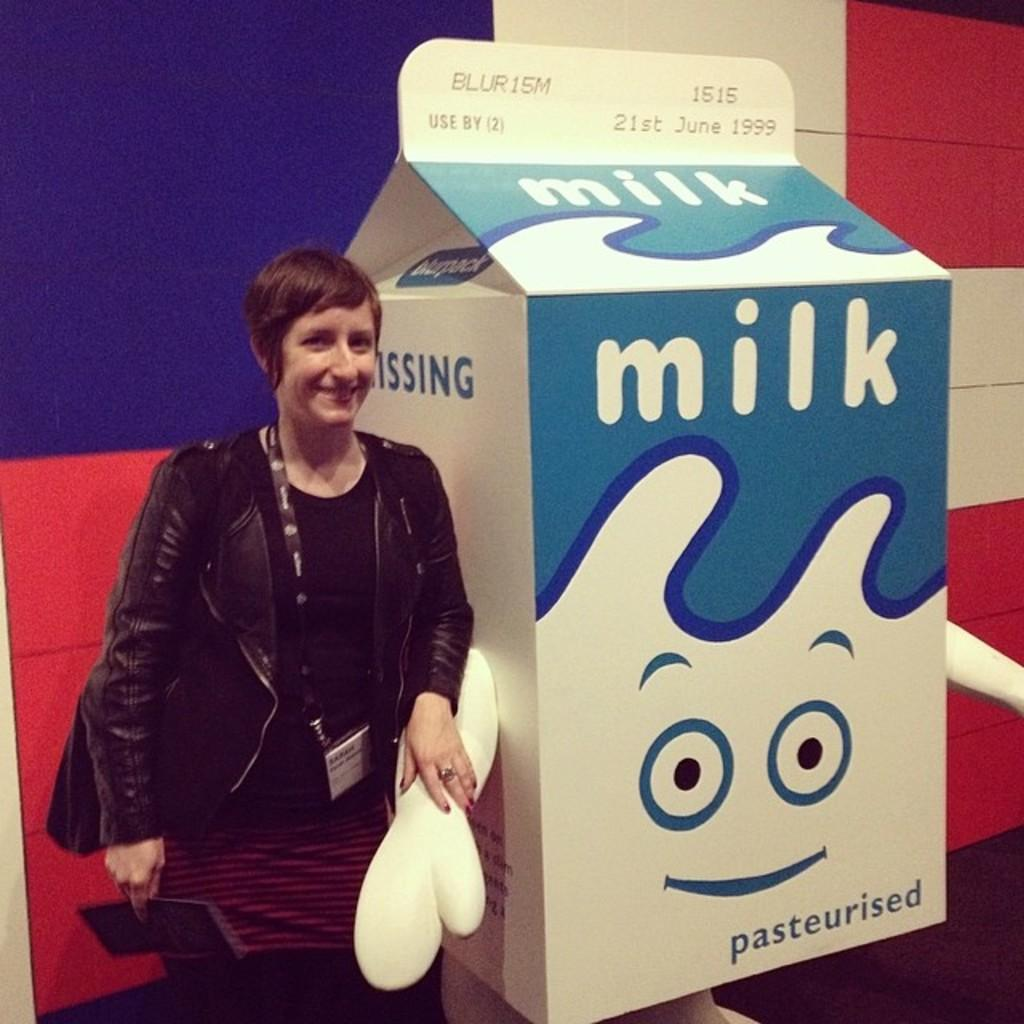What is present in the image? There is a person in the image. What is the person doing in the image? The person is holding an object. What can be seen behind the person in the image? There is a background visible in the image. What is the person's tendency to cry in the image? There is no indication of the person's tendency to cry in the image. 